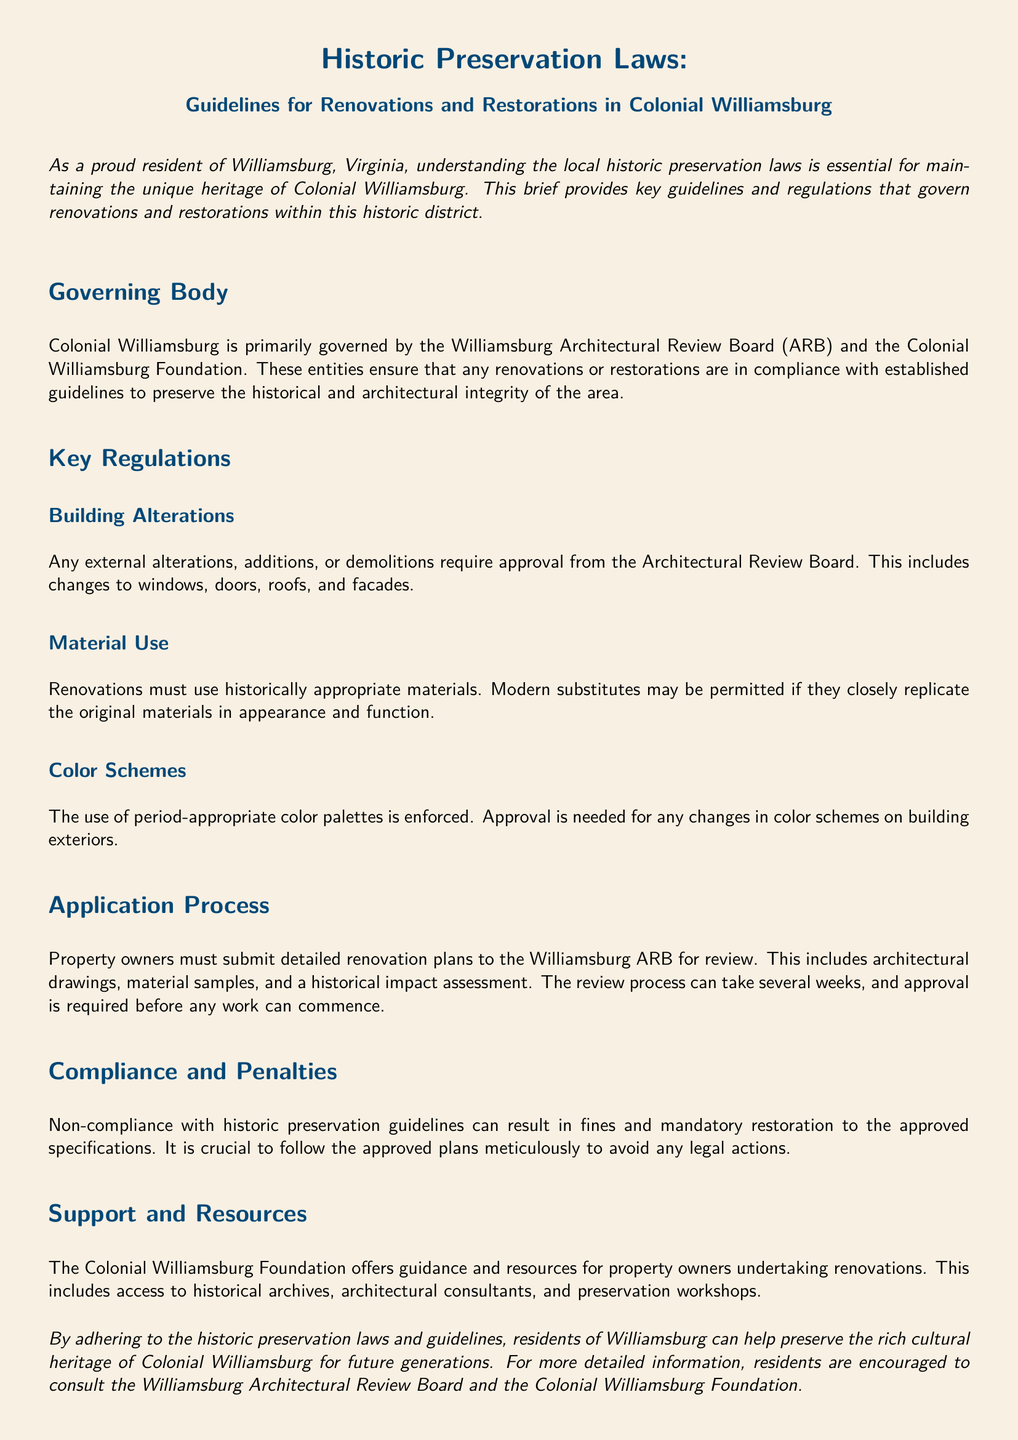What is the governing body for Colonial Williamsburg? The Williamsburg Architectural Review Board (ARB) and the Colonial Williamsburg Foundation are responsible for governance.
Answer: Williamsburg Architectural Review Board and Colonial Williamsburg Foundation What is required for any external alterations? Approval from the Architectural Review Board is necessary for external renovations.
Answer: Approval from the Architectural Review Board What must be used for renovations? Renovations must utilize historically appropriate materials.
Answer: Historically appropriate materials What is needed for changing color schemes? Approval is required for any changes in color schemes on building exteriors.
Answer: Approval How long can the review process take? The review process can take several weeks before work can commence.
Answer: Several weeks What happens in case of non-compliance? Non-compliance can result in fines and mandatory restoration.
Answer: Fines and mandatory restoration What is the main purpose of this legal brief? The brief provides guidelines for renovations and restorations to preserve historical integrity.
Answer: Guidelines for renovations and restorations What type of resources does the Colonial Williamsburg Foundation offer? The Foundation offers guidance and resources for property owners undertaking renovations.
Answer: Guidance and resources What must property owners submit to the ARB? Property owners must submit detailed renovation plans for review.
Answer: Detailed renovation plans 